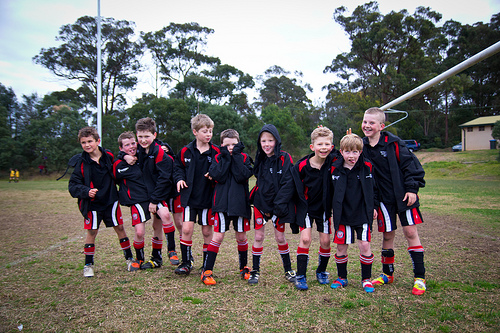<image>
Is the shoe on the ground? Yes. Looking at the image, I can see the shoe is positioned on top of the ground, with the ground providing support. Where is the boy in relation to the forest? Is it behind the forest? No. The boy is not behind the forest. From this viewpoint, the boy appears to be positioned elsewhere in the scene. 